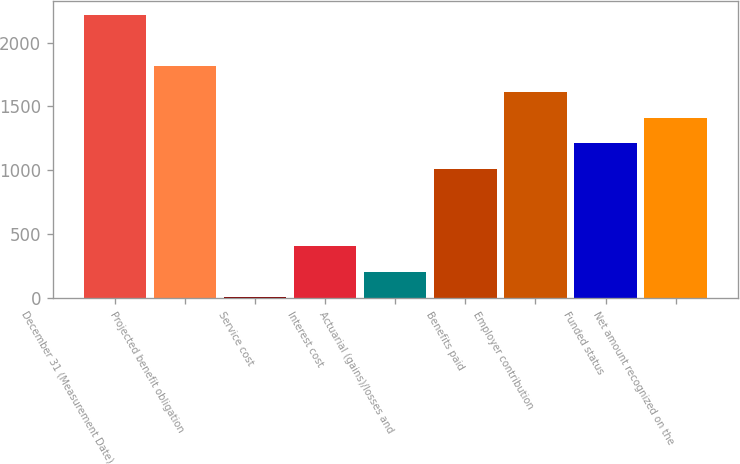<chart> <loc_0><loc_0><loc_500><loc_500><bar_chart><fcel>December 31 (Measurement Date)<fcel>Projected benefit obligation<fcel>Service cost<fcel>Interest cost<fcel>Actuarial (gains)/losses and<fcel>Benefits paid<fcel>Employer contribution<fcel>Funded status<fcel>Net amount recognized on the<nl><fcel>2216<fcel>1814<fcel>5<fcel>407<fcel>206<fcel>1010<fcel>1613<fcel>1211<fcel>1412<nl></chart> 